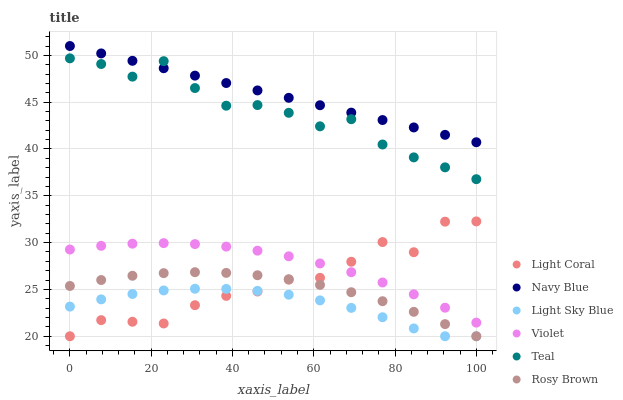Does Light Sky Blue have the minimum area under the curve?
Answer yes or no. Yes. Does Navy Blue have the maximum area under the curve?
Answer yes or no. Yes. Does Rosy Brown have the minimum area under the curve?
Answer yes or no. No. Does Rosy Brown have the maximum area under the curve?
Answer yes or no. No. Is Navy Blue the smoothest?
Answer yes or no. Yes. Is Teal the roughest?
Answer yes or no. Yes. Is Rosy Brown the smoothest?
Answer yes or no. No. Is Rosy Brown the roughest?
Answer yes or no. No. Does Rosy Brown have the lowest value?
Answer yes or no. Yes. Does Teal have the lowest value?
Answer yes or no. No. Does Navy Blue have the highest value?
Answer yes or no. Yes. Does Rosy Brown have the highest value?
Answer yes or no. No. Is Rosy Brown less than Teal?
Answer yes or no. Yes. Is Violet greater than Rosy Brown?
Answer yes or no. Yes. Does Teal intersect Navy Blue?
Answer yes or no. Yes. Is Teal less than Navy Blue?
Answer yes or no. No. Is Teal greater than Navy Blue?
Answer yes or no. No. Does Rosy Brown intersect Teal?
Answer yes or no. No. 